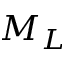<formula> <loc_0><loc_0><loc_500><loc_500>M _ { L }</formula> 